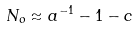<formula> <loc_0><loc_0><loc_500><loc_500>N _ { o } \approx a ^ { - 1 } - 1 - c</formula> 